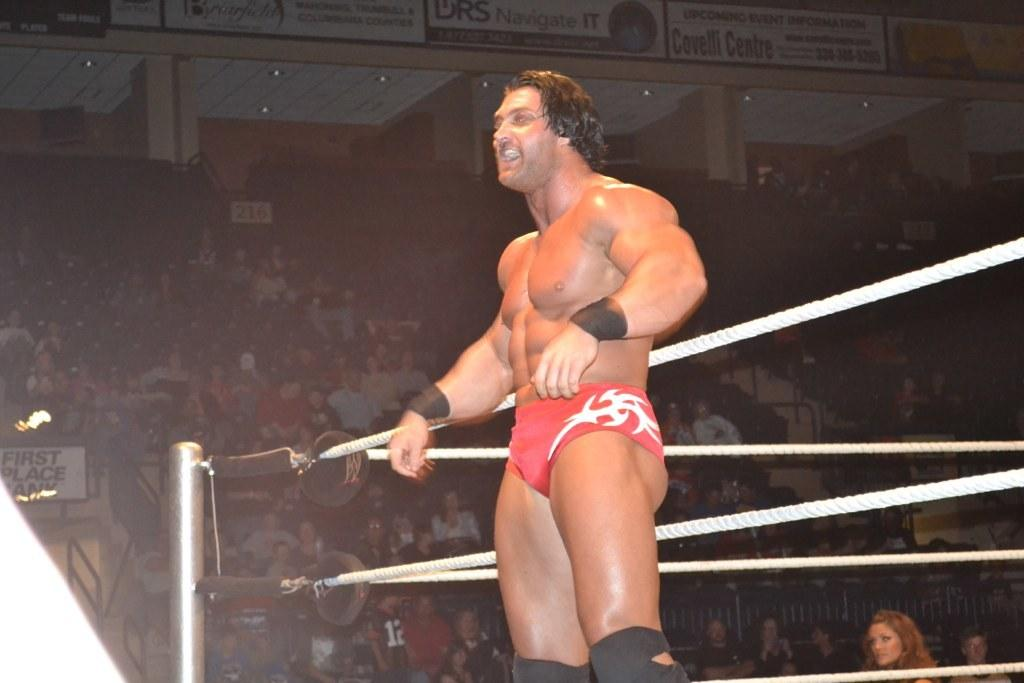<image>
Give a short and clear explanation of the subsequent image. A wrestler stands at the edge of a ring with an advertisement for Covelli Centre in the background. 